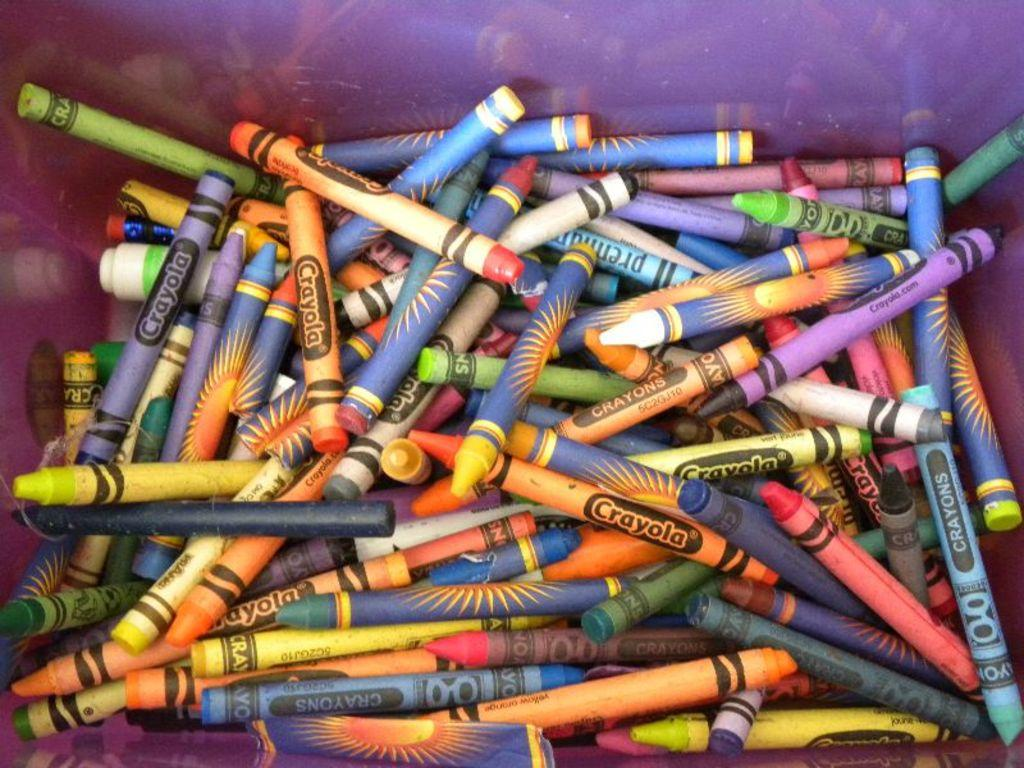<image>
Provide a brief description of the given image. A container filled with a variety of crayola crayons. 